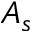<formula> <loc_0><loc_0><loc_500><loc_500>A _ { s }</formula> 